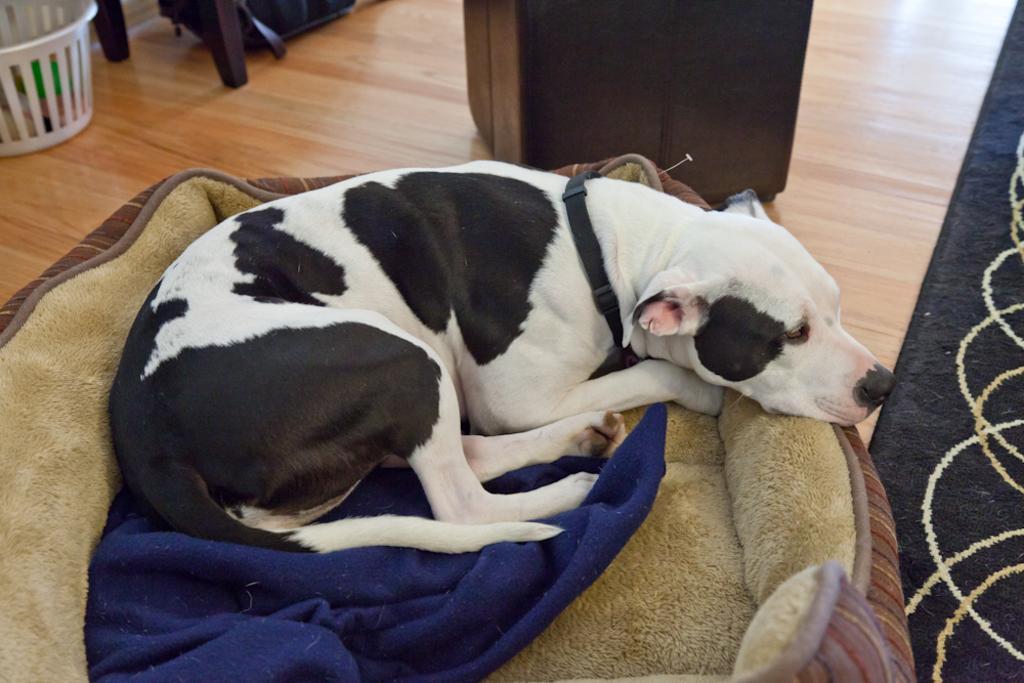Please provide a concise description of this image. In this image we can see a dog on the pet bed and also we can see a basket, cupboard and some other objects on the floor. 